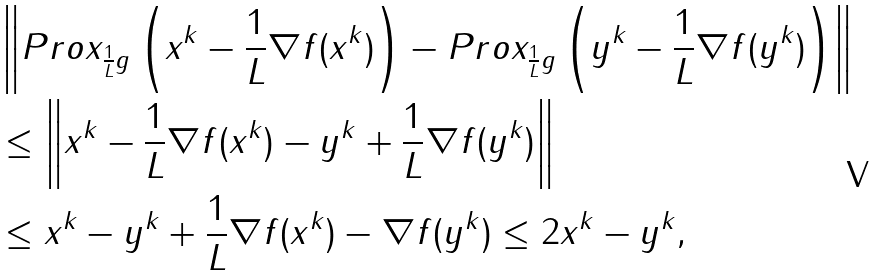<formula> <loc_0><loc_0><loc_500><loc_500>& \left \| P r o x _ { \frac { 1 } { L } g } \left ( x ^ { k } - \frac { 1 } { L } \nabla f ( x ^ { k } ) \right ) - P r o x _ { \frac { 1 } { L } g } \left ( y ^ { k } - \frac { 1 } { L } \nabla f ( y ^ { k } ) \right ) \right \| \\ & \leq \left \| x ^ { k } - \frac { 1 } { L } \nabla f ( x ^ { k } ) - y ^ { k } + \frac { 1 } { L } \nabla f ( y ^ { k } ) \right \| \\ & \leq \| x ^ { k } - y ^ { k } \| + \frac { 1 } { L } \| \nabla f ( x ^ { k } ) - \nabla f ( y ^ { k } ) \| \leq 2 \| x ^ { k } - y ^ { k } \| ,</formula> 